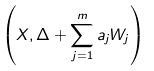<formula> <loc_0><loc_0><loc_500><loc_500>\left ( X , \Delta + \sum _ { j = 1 } ^ { m } a _ { j } W _ { j } \right )</formula> 